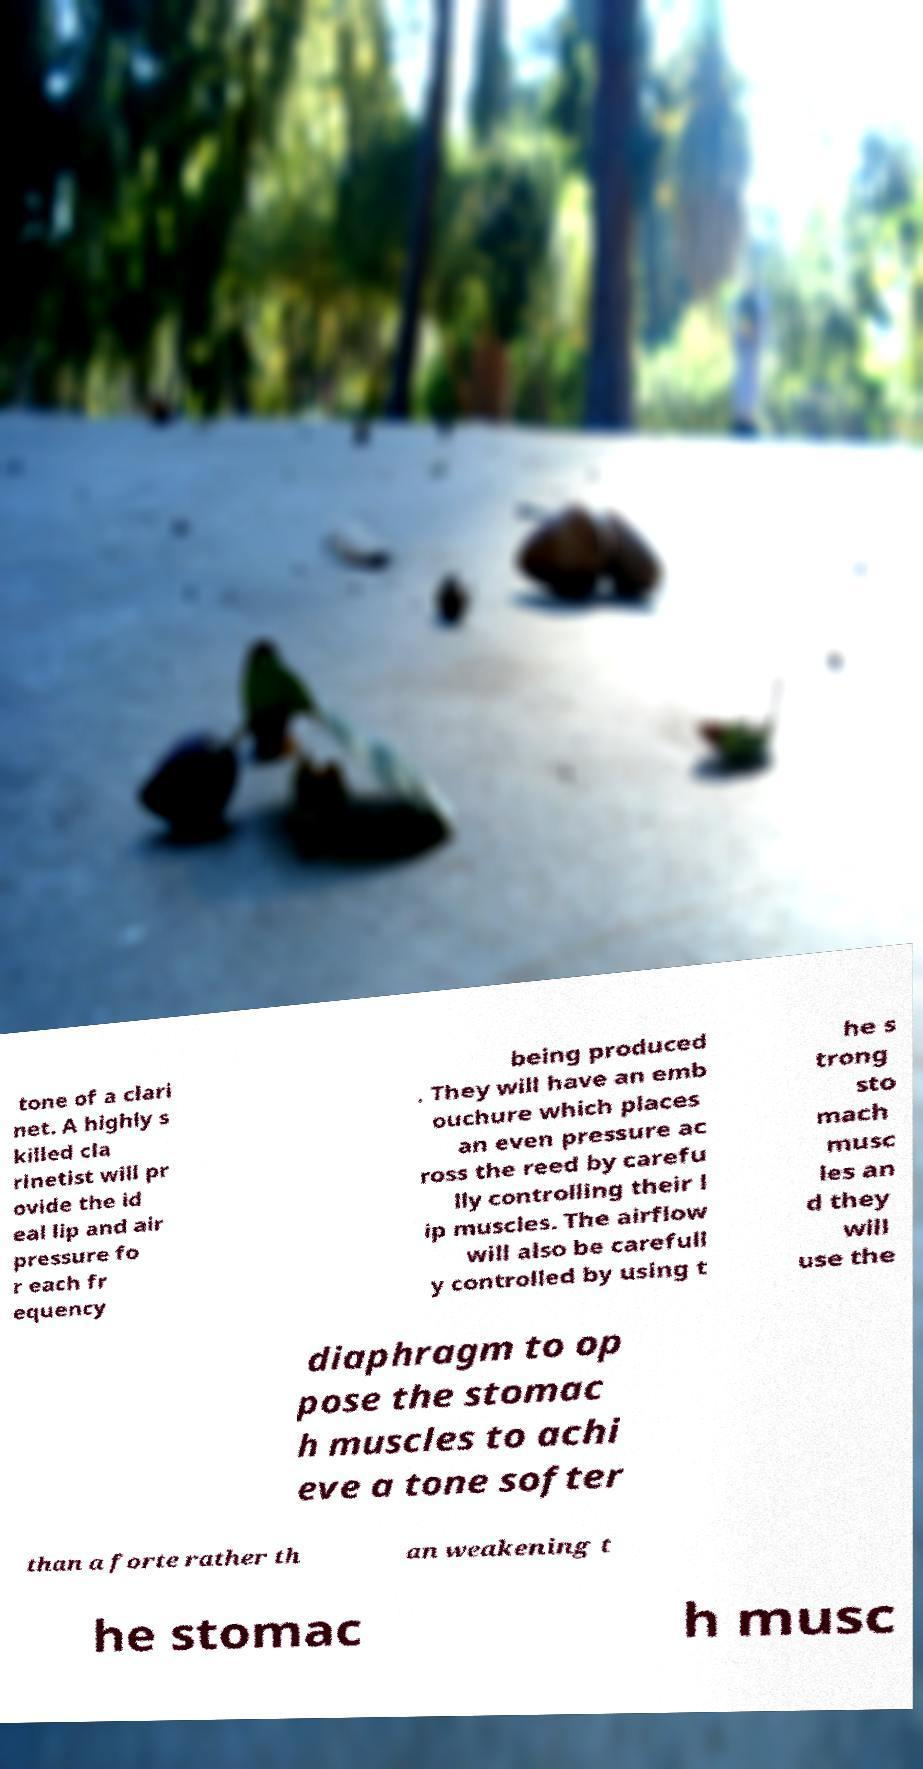Can you read and provide the text displayed in the image?This photo seems to have some interesting text. Can you extract and type it out for me? tone of a clari net. A highly s killed cla rinetist will pr ovide the id eal lip and air pressure fo r each fr equency being produced . They will have an emb ouchure which places an even pressure ac ross the reed by carefu lly controlling their l ip muscles. The airflow will also be carefull y controlled by using t he s trong sto mach musc les an d they will use the diaphragm to op pose the stomac h muscles to achi eve a tone softer than a forte rather th an weakening t he stomac h musc 